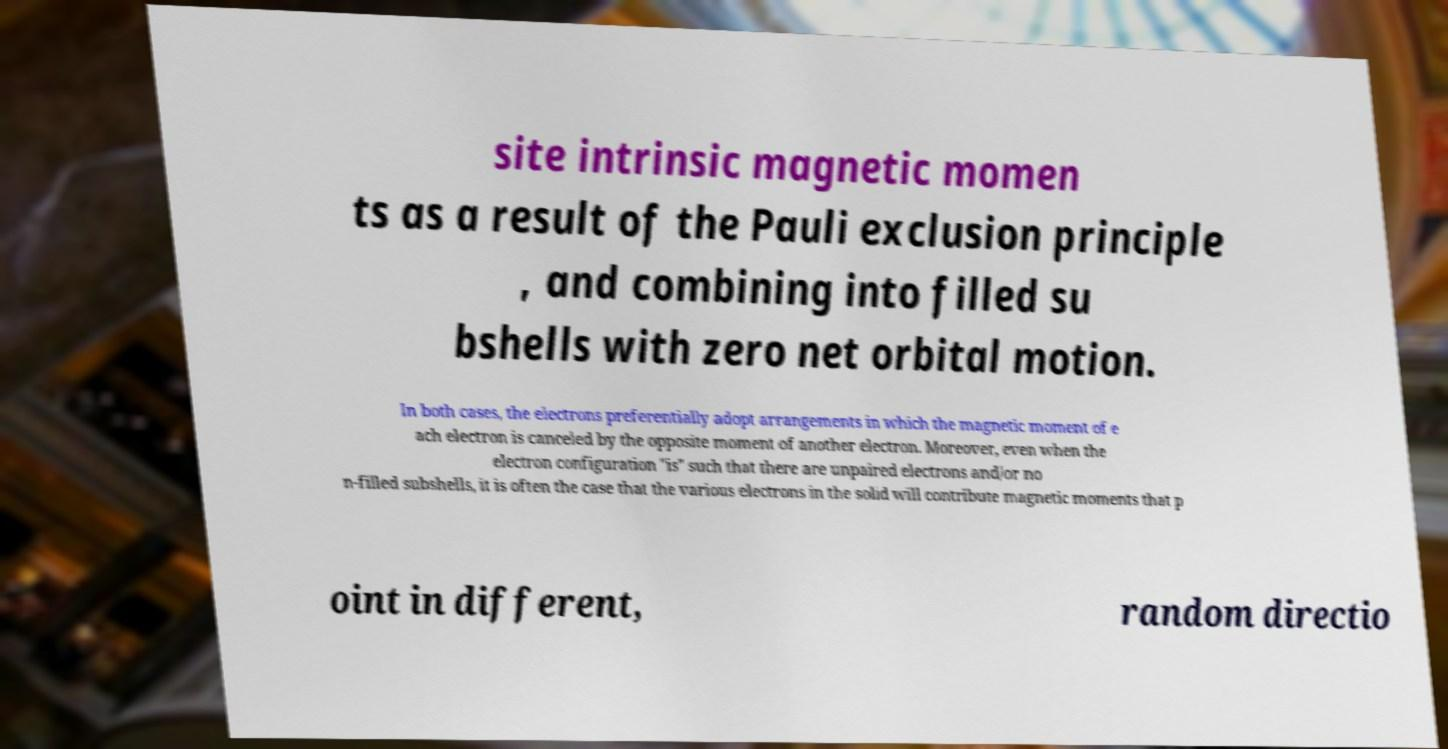For documentation purposes, I need the text within this image transcribed. Could you provide that? site intrinsic magnetic momen ts as a result of the Pauli exclusion principle , and combining into filled su bshells with zero net orbital motion. In both cases, the electrons preferentially adopt arrangements in which the magnetic moment of e ach electron is canceled by the opposite moment of another electron. Moreover, even when the electron configuration "is" such that there are unpaired electrons and/or no n-filled subshells, it is often the case that the various electrons in the solid will contribute magnetic moments that p oint in different, random directio 